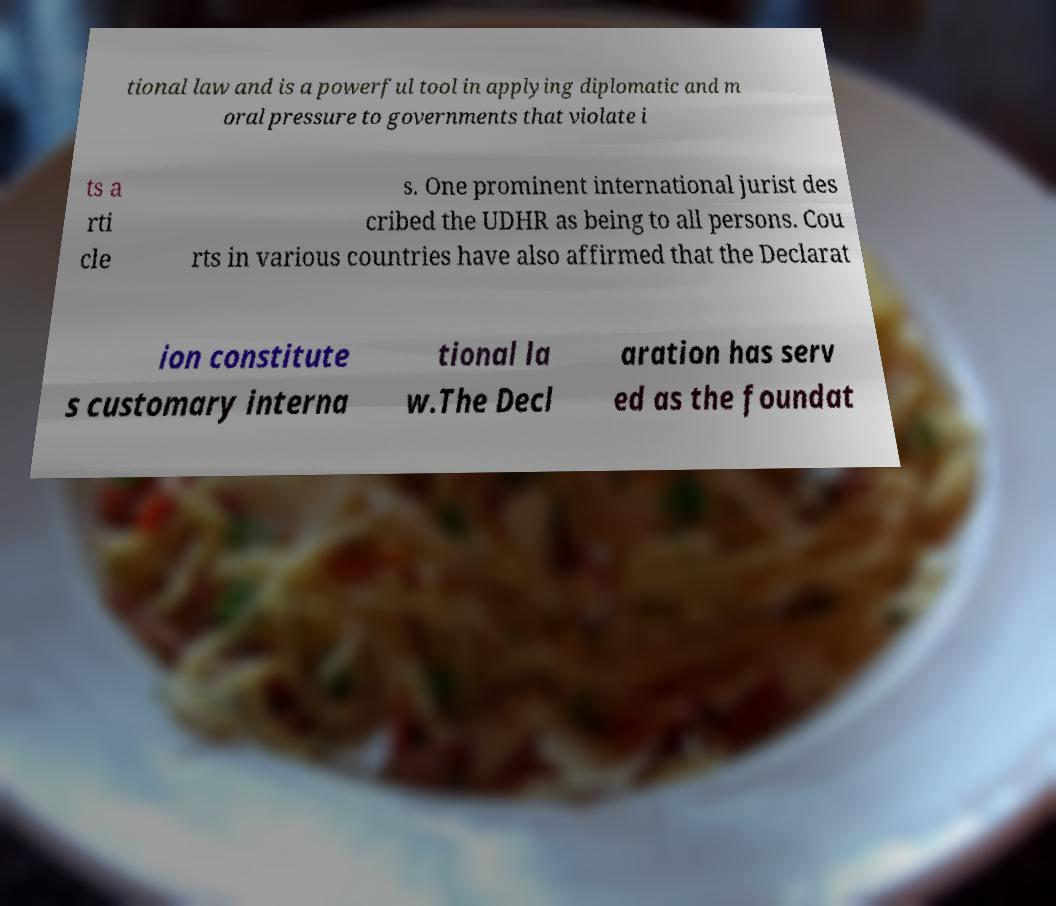What messages or text are displayed in this image? I need them in a readable, typed format. tional law and is a powerful tool in applying diplomatic and m oral pressure to governments that violate i ts a rti cle s. One prominent international jurist des cribed the UDHR as being to all persons. Cou rts in various countries have also affirmed that the Declarat ion constitute s customary interna tional la w.The Decl aration has serv ed as the foundat 